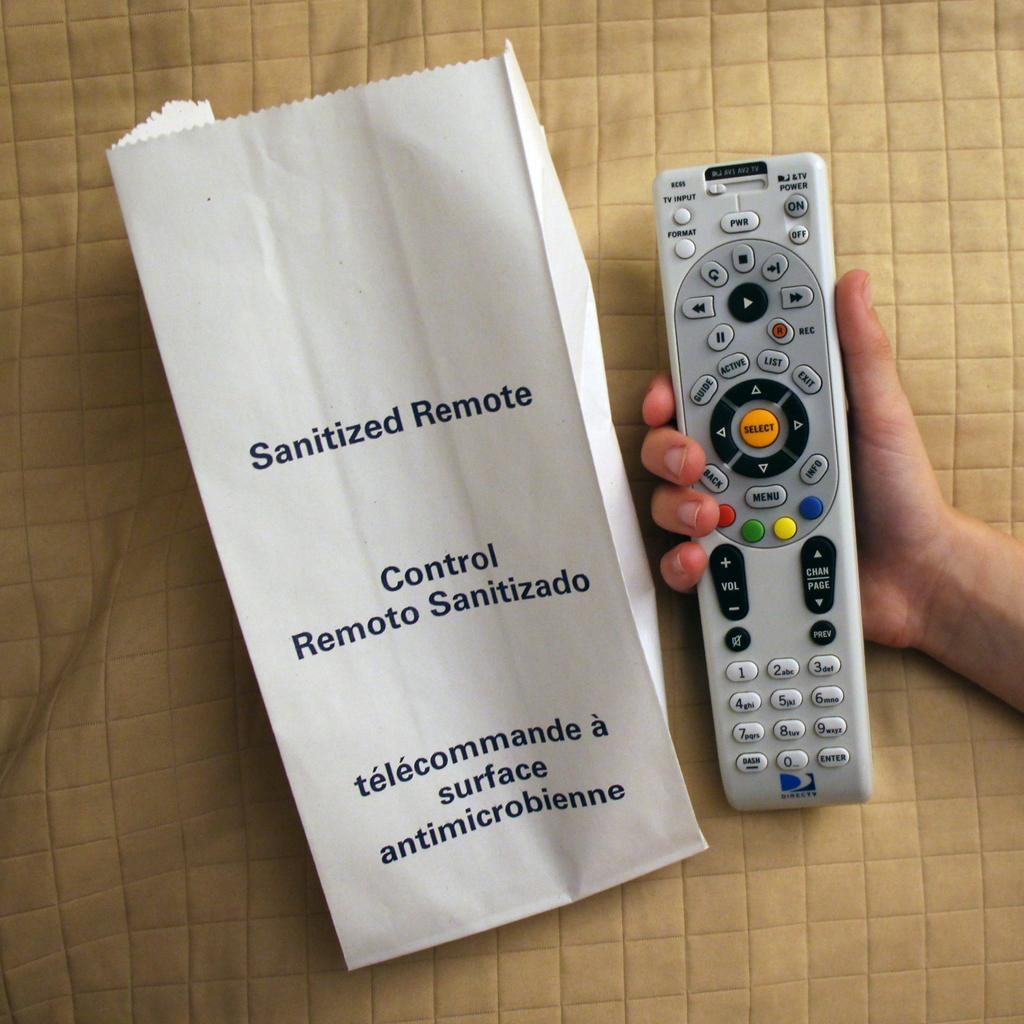<image>
Write a terse but informative summary of the picture. A Direct TV remote next to a paper bag saying that the remote has been sanitized. 